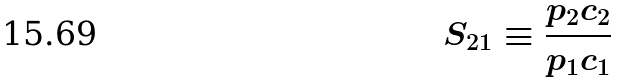<formula> <loc_0><loc_0><loc_500><loc_500>S _ { 2 1 } \equiv \frac { p _ { 2 } c _ { 2 } } { p _ { 1 } c _ { 1 } }</formula> 